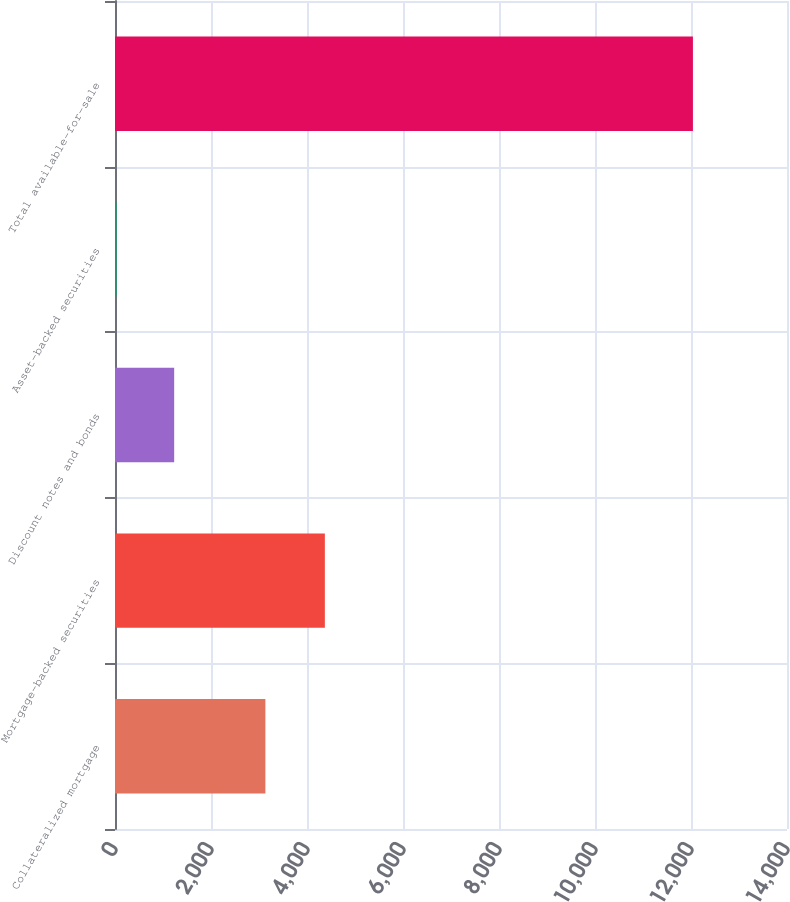Convert chart to OTSL. <chart><loc_0><loc_0><loc_500><loc_500><bar_chart><fcel>Collateralized mortgage<fcel>Mortgage-backed securities<fcel>Discount notes and bonds<fcel>Asset-backed securities<fcel>Total available-for-sale<nl><fcel>3133<fcel>4372<fcel>1232.8<fcel>32<fcel>12040<nl></chart> 